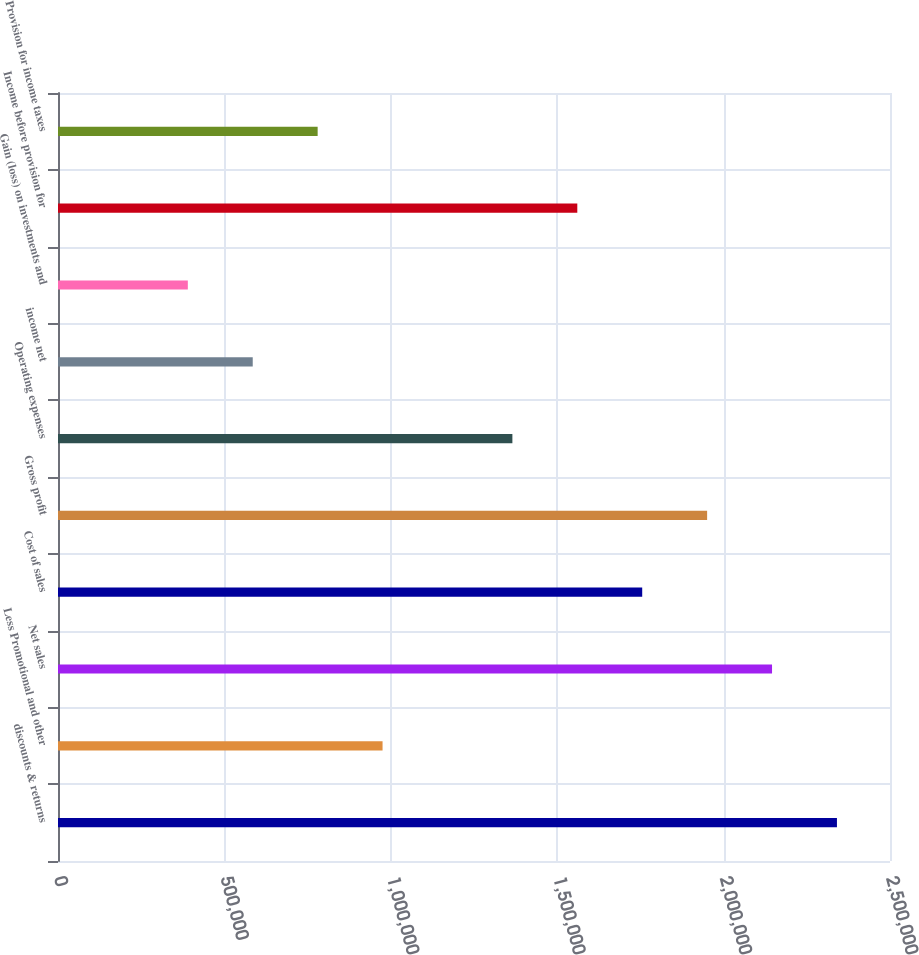Convert chart. <chart><loc_0><loc_0><loc_500><loc_500><bar_chart><fcel>discounts & returns<fcel>Less Promotional and other<fcel>Net sales<fcel>Cost of sales<fcel>Gross profit<fcel>Operating expenses<fcel>income net<fcel>Gain (loss) on investments and<fcel>Income before provision for<fcel>Provision for income taxes<nl><fcel>2.34059e+06<fcel>975246<fcel>2.14554e+06<fcel>1.75544e+06<fcel>1.95049e+06<fcel>1.36534e+06<fcel>585148<fcel>390099<fcel>1.56039e+06<fcel>780197<nl></chart> 